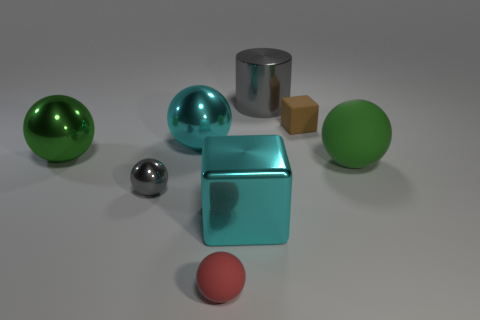The shiny sphere that is the same color as the big rubber object is what size?
Offer a terse response. Large. There is a block that is the same size as the cyan metallic ball; what color is it?
Your answer should be very brief. Cyan. Are there any big blue objects that have the same shape as the tiny red thing?
Give a very brief answer. No. There is a big metallic thing that is the same color as the large rubber object; what shape is it?
Offer a very short reply. Sphere. Is there a metallic object that is in front of the tiny object behind the large cyan metallic thing behind the tiny metal ball?
Provide a short and direct response. Yes. What shape is the gray object that is the same size as the brown block?
Provide a succinct answer. Sphere. There is a large matte object that is the same shape as the tiny gray thing; what color is it?
Offer a terse response. Green. What number of things are tiny rubber cubes or green rubber cylinders?
Ensure brevity in your answer.  1. There is a green shiny object that is behind the tiny rubber ball; is its shape the same as the large thing right of the small brown object?
Make the answer very short. Yes. What is the shape of the rubber thing that is left of the big gray thing?
Make the answer very short. Sphere. 